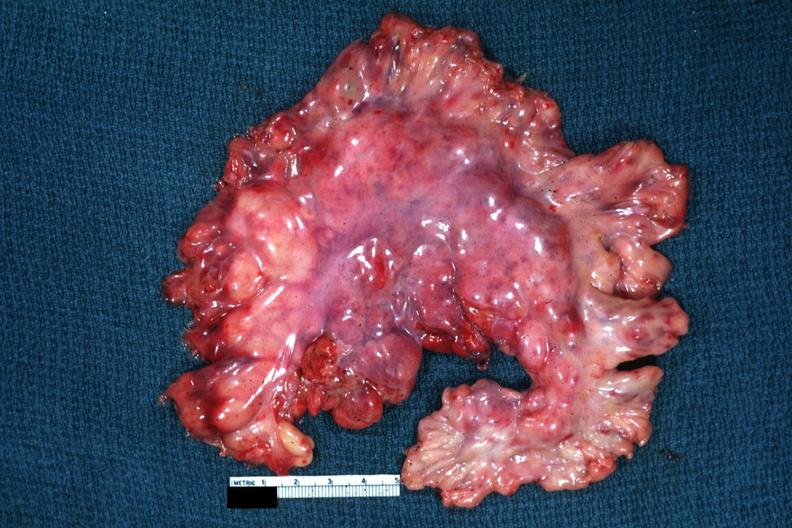what is present?
Answer the question using a single word or phrase. Malignant lymphoma 